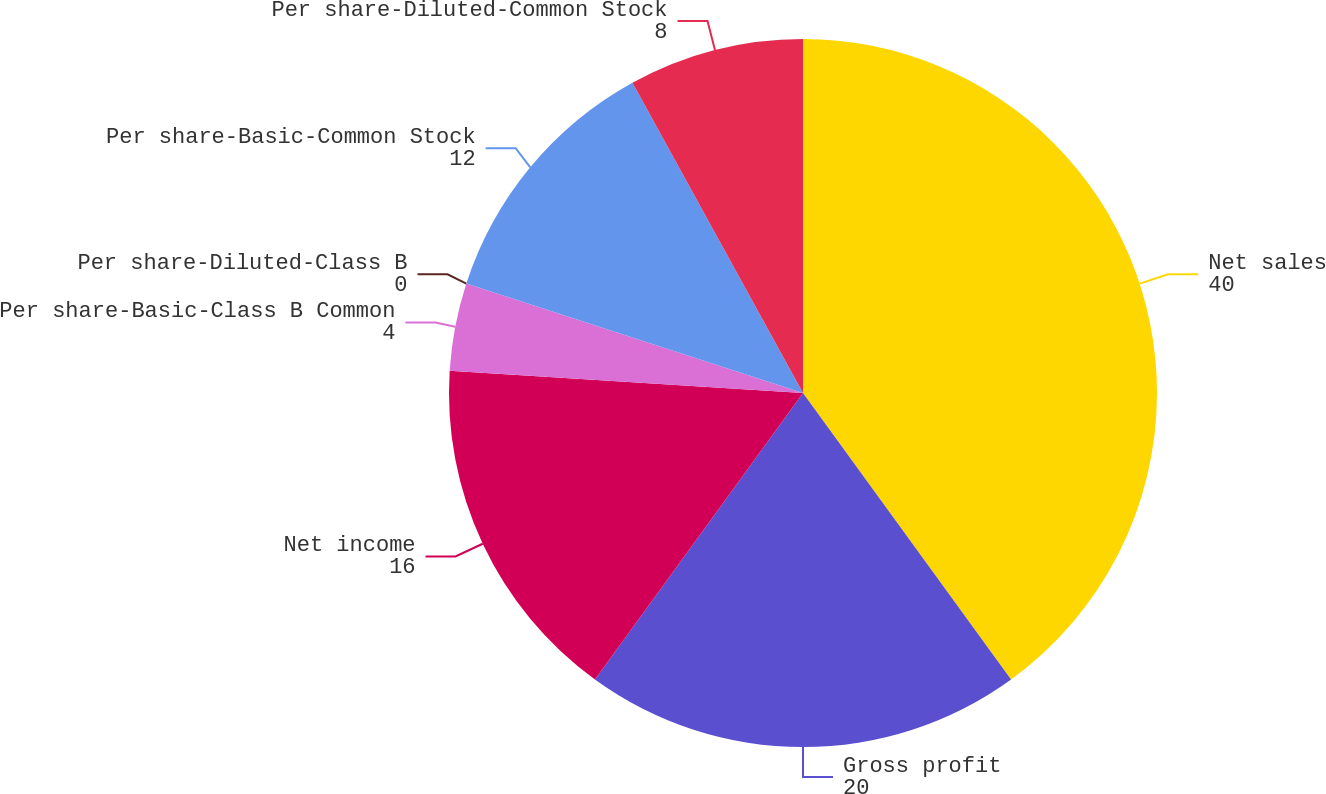Convert chart. <chart><loc_0><loc_0><loc_500><loc_500><pie_chart><fcel>Net sales<fcel>Gross profit<fcel>Net income<fcel>Per share-Basic-Class B Common<fcel>Per share-Diluted-Class B<fcel>Per share-Basic-Common Stock<fcel>Per share-Diluted-Common Stock<nl><fcel>40.0%<fcel>20.0%<fcel>16.0%<fcel>4.0%<fcel>0.0%<fcel>12.0%<fcel>8.0%<nl></chart> 